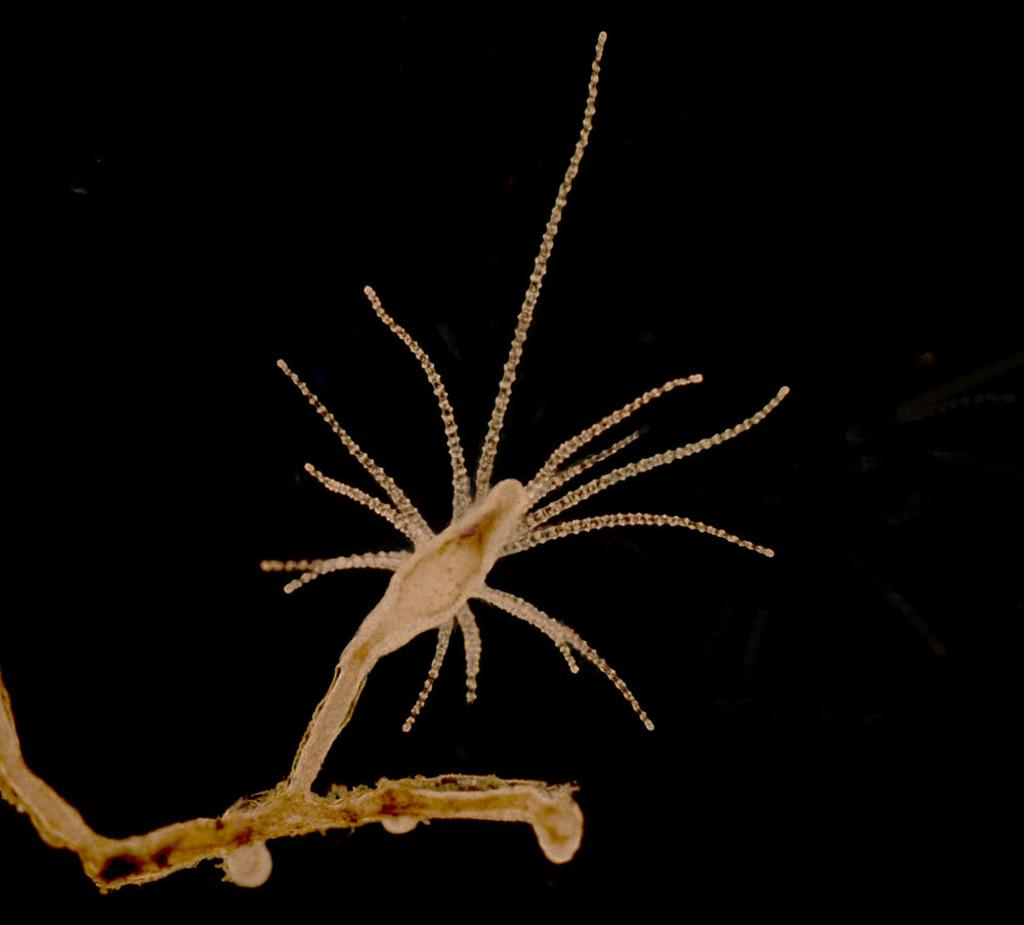What type of creature can be seen in the image? There is an insect in the image. What is the color of the background in the image? The background of the image is black in color. What type of relation does the insect have with the grass in the image? There is no grass present in the image, so it is not possible to determine the insect's relation to grass. What type of muscle can be seen on the insect's body in the image? There is no indication of muscles on the insect's body in the image, as insects have an exoskeleton rather than muscles visible on their bodies. 